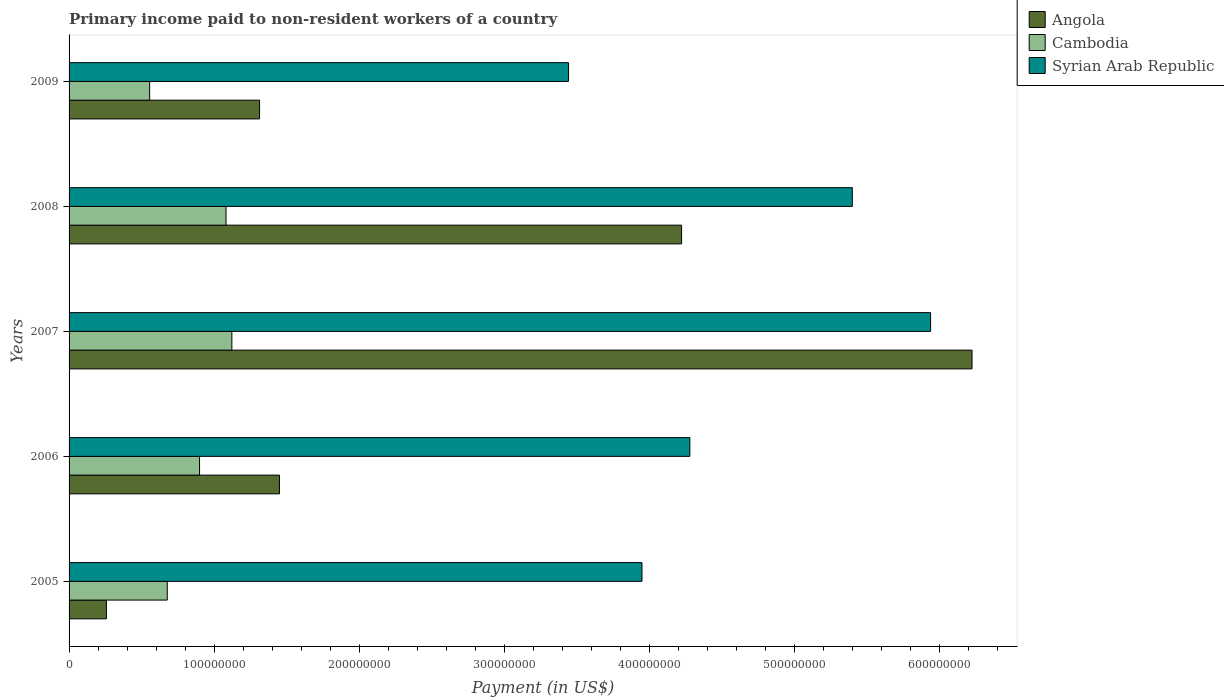How many different coloured bars are there?
Provide a short and direct response. 3. How many groups of bars are there?
Provide a short and direct response. 5. Are the number of bars per tick equal to the number of legend labels?
Offer a terse response. Yes. In how many cases, is the number of bars for a given year not equal to the number of legend labels?
Ensure brevity in your answer.  0. What is the amount paid to workers in Angola in 2008?
Make the answer very short. 4.22e+08. Across all years, what is the maximum amount paid to workers in Syrian Arab Republic?
Ensure brevity in your answer.  5.94e+08. Across all years, what is the minimum amount paid to workers in Cambodia?
Your response must be concise. 5.55e+07. In which year was the amount paid to workers in Angola minimum?
Your answer should be compact. 2005. What is the total amount paid to workers in Angola in the graph?
Provide a short and direct response. 1.35e+09. What is the difference between the amount paid to workers in Cambodia in 2006 and that in 2008?
Ensure brevity in your answer.  -1.83e+07. What is the difference between the amount paid to workers in Cambodia in 2009 and the amount paid to workers in Syrian Arab Republic in 2008?
Make the answer very short. -4.84e+08. What is the average amount paid to workers in Angola per year?
Offer a very short reply. 2.69e+08. In the year 2007, what is the difference between the amount paid to workers in Cambodia and amount paid to workers in Syrian Arab Republic?
Give a very brief answer. -4.82e+08. In how many years, is the amount paid to workers in Angola greater than 120000000 US$?
Give a very brief answer. 4. What is the ratio of the amount paid to workers in Angola in 2005 to that in 2008?
Your response must be concise. 0.06. Is the amount paid to workers in Syrian Arab Republic in 2006 less than that in 2007?
Make the answer very short. Yes. What is the difference between the highest and the second highest amount paid to workers in Angola?
Keep it short and to the point. 2.00e+08. What is the difference between the highest and the lowest amount paid to workers in Syrian Arab Republic?
Ensure brevity in your answer.  2.50e+08. In how many years, is the amount paid to workers in Angola greater than the average amount paid to workers in Angola taken over all years?
Offer a terse response. 2. What does the 1st bar from the top in 2005 represents?
Ensure brevity in your answer.  Syrian Arab Republic. What does the 2nd bar from the bottom in 2009 represents?
Offer a very short reply. Cambodia. How many years are there in the graph?
Make the answer very short. 5. What is the difference between two consecutive major ticks on the X-axis?
Your answer should be very brief. 1.00e+08. Are the values on the major ticks of X-axis written in scientific E-notation?
Offer a terse response. No. Does the graph contain any zero values?
Offer a terse response. No. How many legend labels are there?
Your answer should be very brief. 3. What is the title of the graph?
Your answer should be very brief. Primary income paid to non-resident workers of a country. What is the label or title of the X-axis?
Your answer should be compact. Payment (in US$). What is the label or title of the Y-axis?
Your answer should be very brief. Years. What is the Payment (in US$) in Angola in 2005?
Make the answer very short. 2.58e+07. What is the Payment (in US$) in Cambodia in 2005?
Give a very brief answer. 6.77e+07. What is the Payment (in US$) of Syrian Arab Republic in 2005?
Your answer should be compact. 3.95e+08. What is the Payment (in US$) of Angola in 2006?
Your response must be concise. 1.45e+08. What is the Payment (in US$) of Cambodia in 2006?
Offer a very short reply. 9.00e+07. What is the Payment (in US$) of Syrian Arab Republic in 2006?
Provide a succinct answer. 4.28e+08. What is the Payment (in US$) in Angola in 2007?
Give a very brief answer. 6.23e+08. What is the Payment (in US$) in Cambodia in 2007?
Your answer should be very brief. 1.12e+08. What is the Payment (in US$) in Syrian Arab Republic in 2007?
Offer a terse response. 5.94e+08. What is the Payment (in US$) of Angola in 2008?
Your response must be concise. 4.22e+08. What is the Payment (in US$) in Cambodia in 2008?
Ensure brevity in your answer.  1.08e+08. What is the Payment (in US$) in Syrian Arab Republic in 2008?
Give a very brief answer. 5.40e+08. What is the Payment (in US$) in Angola in 2009?
Provide a short and direct response. 1.31e+08. What is the Payment (in US$) of Cambodia in 2009?
Your answer should be very brief. 5.55e+07. What is the Payment (in US$) in Syrian Arab Republic in 2009?
Your answer should be very brief. 3.44e+08. Across all years, what is the maximum Payment (in US$) in Angola?
Ensure brevity in your answer.  6.23e+08. Across all years, what is the maximum Payment (in US$) of Cambodia?
Keep it short and to the point. 1.12e+08. Across all years, what is the maximum Payment (in US$) of Syrian Arab Republic?
Your answer should be compact. 5.94e+08. Across all years, what is the minimum Payment (in US$) in Angola?
Your answer should be compact. 2.58e+07. Across all years, what is the minimum Payment (in US$) in Cambodia?
Make the answer very short. 5.55e+07. Across all years, what is the minimum Payment (in US$) in Syrian Arab Republic?
Your response must be concise. 3.44e+08. What is the total Payment (in US$) of Angola in the graph?
Ensure brevity in your answer.  1.35e+09. What is the total Payment (in US$) of Cambodia in the graph?
Give a very brief answer. 4.34e+08. What is the total Payment (in US$) of Syrian Arab Republic in the graph?
Your response must be concise. 2.30e+09. What is the difference between the Payment (in US$) in Angola in 2005 and that in 2006?
Provide a succinct answer. -1.19e+08. What is the difference between the Payment (in US$) of Cambodia in 2005 and that in 2006?
Offer a very short reply. -2.23e+07. What is the difference between the Payment (in US$) in Syrian Arab Republic in 2005 and that in 2006?
Provide a succinct answer. -3.30e+07. What is the difference between the Payment (in US$) of Angola in 2005 and that in 2007?
Provide a succinct answer. -5.97e+08. What is the difference between the Payment (in US$) in Cambodia in 2005 and that in 2007?
Your answer should be compact. -4.45e+07. What is the difference between the Payment (in US$) in Syrian Arab Republic in 2005 and that in 2007?
Give a very brief answer. -1.99e+08. What is the difference between the Payment (in US$) in Angola in 2005 and that in 2008?
Your answer should be compact. -3.97e+08. What is the difference between the Payment (in US$) in Cambodia in 2005 and that in 2008?
Make the answer very short. -4.05e+07. What is the difference between the Payment (in US$) of Syrian Arab Republic in 2005 and that in 2008?
Make the answer very short. -1.45e+08. What is the difference between the Payment (in US$) of Angola in 2005 and that in 2009?
Provide a short and direct response. -1.06e+08. What is the difference between the Payment (in US$) in Cambodia in 2005 and that in 2009?
Your answer should be very brief. 1.22e+07. What is the difference between the Payment (in US$) in Syrian Arab Republic in 2005 and that in 2009?
Your answer should be very brief. 5.06e+07. What is the difference between the Payment (in US$) of Angola in 2006 and that in 2007?
Give a very brief answer. -4.78e+08. What is the difference between the Payment (in US$) in Cambodia in 2006 and that in 2007?
Provide a succinct answer. -2.23e+07. What is the difference between the Payment (in US$) of Syrian Arab Republic in 2006 and that in 2007?
Your response must be concise. -1.66e+08. What is the difference between the Payment (in US$) of Angola in 2006 and that in 2008?
Keep it short and to the point. -2.77e+08. What is the difference between the Payment (in US$) of Cambodia in 2006 and that in 2008?
Keep it short and to the point. -1.83e+07. What is the difference between the Payment (in US$) in Syrian Arab Republic in 2006 and that in 2008?
Ensure brevity in your answer.  -1.12e+08. What is the difference between the Payment (in US$) of Angola in 2006 and that in 2009?
Make the answer very short. 1.37e+07. What is the difference between the Payment (in US$) of Cambodia in 2006 and that in 2009?
Provide a succinct answer. 3.44e+07. What is the difference between the Payment (in US$) of Syrian Arab Republic in 2006 and that in 2009?
Give a very brief answer. 8.36e+07. What is the difference between the Payment (in US$) in Angola in 2007 and that in 2008?
Provide a succinct answer. 2.00e+08. What is the difference between the Payment (in US$) in Cambodia in 2007 and that in 2008?
Offer a terse response. 4.02e+06. What is the difference between the Payment (in US$) of Syrian Arab Republic in 2007 and that in 2008?
Provide a short and direct response. 5.40e+07. What is the difference between the Payment (in US$) of Angola in 2007 and that in 2009?
Offer a very short reply. 4.91e+08. What is the difference between the Payment (in US$) in Cambodia in 2007 and that in 2009?
Give a very brief answer. 5.67e+07. What is the difference between the Payment (in US$) of Syrian Arab Republic in 2007 and that in 2009?
Your answer should be compact. 2.50e+08. What is the difference between the Payment (in US$) of Angola in 2008 and that in 2009?
Your response must be concise. 2.91e+08. What is the difference between the Payment (in US$) in Cambodia in 2008 and that in 2009?
Ensure brevity in your answer.  5.27e+07. What is the difference between the Payment (in US$) in Syrian Arab Republic in 2008 and that in 2009?
Offer a very short reply. 1.96e+08. What is the difference between the Payment (in US$) of Angola in 2005 and the Payment (in US$) of Cambodia in 2006?
Provide a succinct answer. -6.42e+07. What is the difference between the Payment (in US$) of Angola in 2005 and the Payment (in US$) of Syrian Arab Republic in 2006?
Make the answer very short. -4.02e+08. What is the difference between the Payment (in US$) in Cambodia in 2005 and the Payment (in US$) in Syrian Arab Republic in 2006?
Make the answer very short. -3.60e+08. What is the difference between the Payment (in US$) in Angola in 2005 and the Payment (in US$) in Cambodia in 2007?
Provide a succinct answer. -8.65e+07. What is the difference between the Payment (in US$) in Angola in 2005 and the Payment (in US$) in Syrian Arab Republic in 2007?
Keep it short and to the point. -5.68e+08. What is the difference between the Payment (in US$) in Cambodia in 2005 and the Payment (in US$) in Syrian Arab Republic in 2007?
Give a very brief answer. -5.26e+08. What is the difference between the Payment (in US$) of Angola in 2005 and the Payment (in US$) of Cambodia in 2008?
Offer a very short reply. -8.25e+07. What is the difference between the Payment (in US$) in Angola in 2005 and the Payment (in US$) in Syrian Arab Republic in 2008?
Offer a very short reply. -5.14e+08. What is the difference between the Payment (in US$) of Cambodia in 2005 and the Payment (in US$) of Syrian Arab Republic in 2008?
Your answer should be very brief. -4.72e+08. What is the difference between the Payment (in US$) in Angola in 2005 and the Payment (in US$) in Cambodia in 2009?
Offer a terse response. -2.98e+07. What is the difference between the Payment (in US$) in Angola in 2005 and the Payment (in US$) in Syrian Arab Republic in 2009?
Your response must be concise. -3.19e+08. What is the difference between the Payment (in US$) of Cambodia in 2005 and the Payment (in US$) of Syrian Arab Republic in 2009?
Your response must be concise. -2.77e+08. What is the difference between the Payment (in US$) of Angola in 2006 and the Payment (in US$) of Cambodia in 2007?
Make the answer very short. 3.28e+07. What is the difference between the Payment (in US$) of Angola in 2006 and the Payment (in US$) of Syrian Arab Republic in 2007?
Provide a short and direct response. -4.49e+08. What is the difference between the Payment (in US$) in Cambodia in 2006 and the Payment (in US$) in Syrian Arab Republic in 2007?
Provide a succinct answer. -5.04e+08. What is the difference between the Payment (in US$) in Angola in 2006 and the Payment (in US$) in Cambodia in 2008?
Offer a terse response. 3.68e+07. What is the difference between the Payment (in US$) in Angola in 2006 and the Payment (in US$) in Syrian Arab Republic in 2008?
Give a very brief answer. -3.95e+08. What is the difference between the Payment (in US$) in Cambodia in 2006 and the Payment (in US$) in Syrian Arab Republic in 2008?
Give a very brief answer. -4.50e+08. What is the difference between the Payment (in US$) of Angola in 2006 and the Payment (in US$) of Cambodia in 2009?
Provide a short and direct response. 8.95e+07. What is the difference between the Payment (in US$) in Angola in 2006 and the Payment (in US$) in Syrian Arab Republic in 2009?
Your answer should be compact. -1.99e+08. What is the difference between the Payment (in US$) in Cambodia in 2006 and the Payment (in US$) in Syrian Arab Republic in 2009?
Give a very brief answer. -2.54e+08. What is the difference between the Payment (in US$) in Angola in 2007 and the Payment (in US$) in Cambodia in 2008?
Provide a succinct answer. 5.14e+08. What is the difference between the Payment (in US$) in Angola in 2007 and the Payment (in US$) in Syrian Arab Republic in 2008?
Give a very brief answer. 8.25e+07. What is the difference between the Payment (in US$) of Cambodia in 2007 and the Payment (in US$) of Syrian Arab Republic in 2008?
Ensure brevity in your answer.  -4.28e+08. What is the difference between the Payment (in US$) in Angola in 2007 and the Payment (in US$) in Cambodia in 2009?
Provide a succinct answer. 5.67e+08. What is the difference between the Payment (in US$) of Angola in 2007 and the Payment (in US$) of Syrian Arab Republic in 2009?
Provide a succinct answer. 2.78e+08. What is the difference between the Payment (in US$) of Cambodia in 2007 and the Payment (in US$) of Syrian Arab Republic in 2009?
Keep it short and to the point. -2.32e+08. What is the difference between the Payment (in US$) in Angola in 2008 and the Payment (in US$) in Cambodia in 2009?
Offer a terse response. 3.67e+08. What is the difference between the Payment (in US$) of Angola in 2008 and the Payment (in US$) of Syrian Arab Republic in 2009?
Make the answer very short. 7.79e+07. What is the difference between the Payment (in US$) in Cambodia in 2008 and the Payment (in US$) in Syrian Arab Republic in 2009?
Ensure brevity in your answer.  -2.36e+08. What is the average Payment (in US$) of Angola per year?
Offer a very short reply. 2.69e+08. What is the average Payment (in US$) in Cambodia per year?
Keep it short and to the point. 8.67e+07. What is the average Payment (in US$) in Syrian Arab Republic per year?
Your answer should be very brief. 4.60e+08. In the year 2005, what is the difference between the Payment (in US$) of Angola and Payment (in US$) of Cambodia?
Ensure brevity in your answer.  -4.20e+07. In the year 2005, what is the difference between the Payment (in US$) in Angola and Payment (in US$) in Syrian Arab Republic?
Offer a terse response. -3.69e+08. In the year 2005, what is the difference between the Payment (in US$) in Cambodia and Payment (in US$) in Syrian Arab Republic?
Provide a short and direct response. -3.27e+08. In the year 2006, what is the difference between the Payment (in US$) in Angola and Payment (in US$) in Cambodia?
Your answer should be compact. 5.51e+07. In the year 2006, what is the difference between the Payment (in US$) in Angola and Payment (in US$) in Syrian Arab Republic?
Keep it short and to the point. -2.83e+08. In the year 2006, what is the difference between the Payment (in US$) in Cambodia and Payment (in US$) in Syrian Arab Republic?
Provide a succinct answer. -3.38e+08. In the year 2007, what is the difference between the Payment (in US$) in Angola and Payment (in US$) in Cambodia?
Offer a terse response. 5.10e+08. In the year 2007, what is the difference between the Payment (in US$) in Angola and Payment (in US$) in Syrian Arab Republic?
Provide a short and direct response. 2.86e+07. In the year 2007, what is the difference between the Payment (in US$) of Cambodia and Payment (in US$) of Syrian Arab Republic?
Ensure brevity in your answer.  -4.82e+08. In the year 2008, what is the difference between the Payment (in US$) of Angola and Payment (in US$) of Cambodia?
Offer a terse response. 3.14e+08. In the year 2008, what is the difference between the Payment (in US$) in Angola and Payment (in US$) in Syrian Arab Republic?
Make the answer very short. -1.18e+08. In the year 2008, what is the difference between the Payment (in US$) of Cambodia and Payment (in US$) of Syrian Arab Republic?
Your answer should be compact. -4.32e+08. In the year 2009, what is the difference between the Payment (in US$) of Angola and Payment (in US$) of Cambodia?
Provide a succinct answer. 7.58e+07. In the year 2009, what is the difference between the Payment (in US$) of Angola and Payment (in US$) of Syrian Arab Republic?
Provide a succinct answer. -2.13e+08. In the year 2009, what is the difference between the Payment (in US$) of Cambodia and Payment (in US$) of Syrian Arab Republic?
Make the answer very short. -2.89e+08. What is the ratio of the Payment (in US$) in Angola in 2005 to that in 2006?
Make the answer very short. 0.18. What is the ratio of the Payment (in US$) of Cambodia in 2005 to that in 2006?
Your answer should be compact. 0.75. What is the ratio of the Payment (in US$) in Syrian Arab Republic in 2005 to that in 2006?
Give a very brief answer. 0.92. What is the ratio of the Payment (in US$) in Angola in 2005 to that in 2007?
Keep it short and to the point. 0.04. What is the ratio of the Payment (in US$) in Cambodia in 2005 to that in 2007?
Your answer should be compact. 0.6. What is the ratio of the Payment (in US$) in Syrian Arab Republic in 2005 to that in 2007?
Make the answer very short. 0.67. What is the ratio of the Payment (in US$) of Angola in 2005 to that in 2008?
Give a very brief answer. 0.06. What is the ratio of the Payment (in US$) of Cambodia in 2005 to that in 2008?
Your response must be concise. 0.63. What is the ratio of the Payment (in US$) in Syrian Arab Republic in 2005 to that in 2008?
Your answer should be compact. 0.73. What is the ratio of the Payment (in US$) of Angola in 2005 to that in 2009?
Give a very brief answer. 0.2. What is the ratio of the Payment (in US$) of Cambodia in 2005 to that in 2009?
Provide a succinct answer. 1.22. What is the ratio of the Payment (in US$) in Syrian Arab Republic in 2005 to that in 2009?
Make the answer very short. 1.15. What is the ratio of the Payment (in US$) in Angola in 2006 to that in 2007?
Provide a succinct answer. 0.23. What is the ratio of the Payment (in US$) in Cambodia in 2006 to that in 2007?
Your answer should be very brief. 0.8. What is the ratio of the Payment (in US$) of Syrian Arab Republic in 2006 to that in 2007?
Offer a very short reply. 0.72. What is the ratio of the Payment (in US$) of Angola in 2006 to that in 2008?
Keep it short and to the point. 0.34. What is the ratio of the Payment (in US$) in Cambodia in 2006 to that in 2008?
Keep it short and to the point. 0.83. What is the ratio of the Payment (in US$) in Syrian Arab Republic in 2006 to that in 2008?
Your answer should be compact. 0.79. What is the ratio of the Payment (in US$) in Angola in 2006 to that in 2009?
Offer a very short reply. 1.1. What is the ratio of the Payment (in US$) of Cambodia in 2006 to that in 2009?
Provide a short and direct response. 1.62. What is the ratio of the Payment (in US$) of Syrian Arab Republic in 2006 to that in 2009?
Make the answer very short. 1.24. What is the ratio of the Payment (in US$) in Angola in 2007 to that in 2008?
Keep it short and to the point. 1.47. What is the ratio of the Payment (in US$) of Cambodia in 2007 to that in 2008?
Offer a very short reply. 1.04. What is the ratio of the Payment (in US$) in Syrian Arab Republic in 2007 to that in 2008?
Offer a very short reply. 1.1. What is the ratio of the Payment (in US$) in Angola in 2007 to that in 2009?
Provide a short and direct response. 4.74. What is the ratio of the Payment (in US$) in Cambodia in 2007 to that in 2009?
Provide a succinct answer. 2.02. What is the ratio of the Payment (in US$) in Syrian Arab Republic in 2007 to that in 2009?
Make the answer very short. 1.72. What is the ratio of the Payment (in US$) in Angola in 2008 to that in 2009?
Give a very brief answer. 3.22. What is the ratio of the Payment (in US$) in Cambodia in 2008 to that in 2009?
Give a very brief answer. 1.95. What is the ratio of the Payment (in US$) in Syrian Arab Republic in 2008 to that in 2009?
Offer a terse response. 1.57. What is the difference between the highest and the second highest Payment (in US$) of Angola?
Provide a succinct answer. 2.00e+08. What is the difference between the highest and the second highest Payment (in US$) in Cambodia?
Make the answer very short. 4.02e+06. What is the difference between the highest and the second highest Payment (in US$) of Syrian Arab Republic?
Your answer should be very brief. 5.40e+07. What is the difference between the highest and the lowest Payment (in US$) of Angola?
Your response must be concise. 5.97e+08. What is the difference between the highest and the lowest Payment (in US$) in Cambodia?
Offer a very short reply. 5.67e+07. What is the difference between the highest and the lowest Payment (in US$) of Syrian Arab Republic?
Your answer should be very brief. 2.50e+08. 